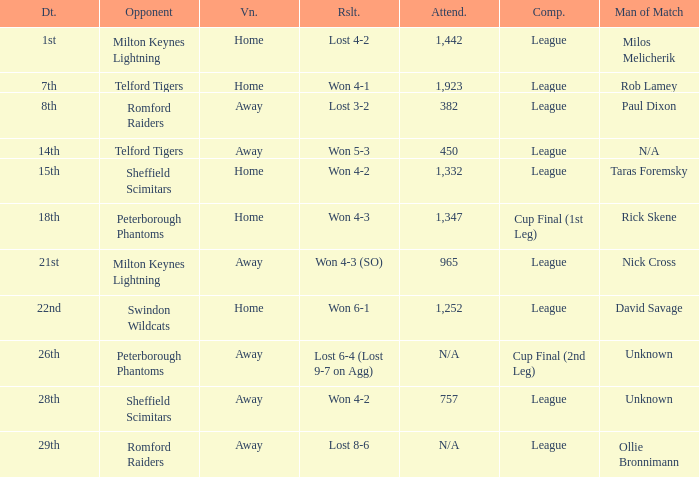Who was the Man of the Match when the opponent was Milton Keynes Lightning and the venue was Away? Nick Cross. 